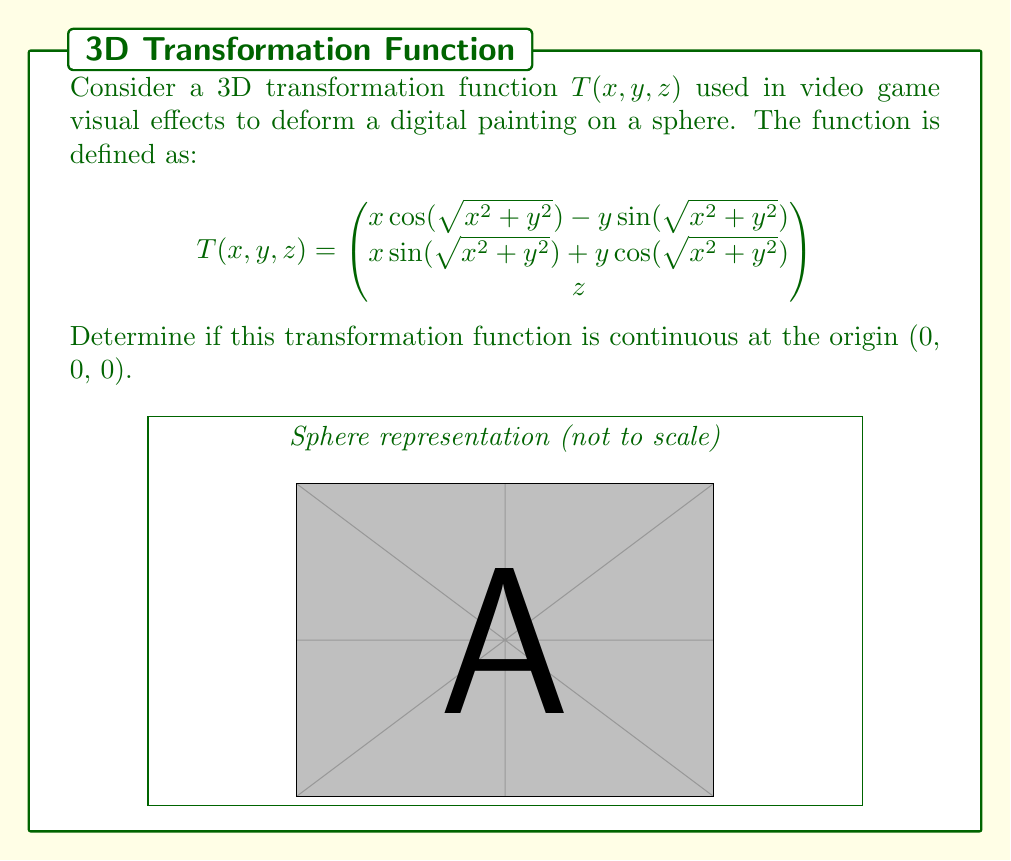Can you answer this question? To determine the continuity of $T(x, y, z)$ at the origin, we need to check if the limit of the function exists as $(x, y, z)$ approaches $(0, 0, 0)$ and if it equals $T(0, 0, 0)$.

Step 1: Evaluate $T(0, 0, 0)$
$$T(0, 0, 0) = \begin{pmatrix}
0\cos(0) - 0\sin(0) \\
0\sin(0) + 0\cos(0) \\
0
\end{pmatrix} = \begin{pmatrix}
0 \\
0 \\
0
\end{pmatrix}$$

Step 2: Examine the limit as $(x, y, z)$ approaches $(0, 0, 0)$

For the first two components:
$$\lim_{(x,y,z)\to(0,0,0)} x\cos(\sqrt{x^2 + y^2}) - y\sin(\sqrt{x^2 + y^2})$$
$$\lim_{(x,y,z)\to(0,0,0)} x\sin(\sqrt{x^2 + y^2}) + y\cos(\sqrt{x^2 + y^2})$$

As $(x, y) \to (0, 0)$, $\sqrt{x^2 + y^2} \to 0$. The sine and cosine terms are bounded, and $x$ and $y$ approach 0, so both these limits equal 0.

For the third component:
$$\lim_{(x,y,z)\to(0,0,0)} z = 0$$

Step 3: Compare the limit to $T(0, 0, 0)$

The limit of $T(x, y, z)$ as $(x, y, z)$ approaches $(0, 0, 0)$ is:
$$\lim_{(x,y,z)\to(0,0,0)} T(x, y, z) = \begin{pmatrix}
0 \\
0 \\
0
\end{pmatrix}$$

This equals $T(0, 0, 0)$, so the function is continuous at the origin.

Step 4: Check for potential issues

The function is well-defined at all points, including the origin. The sine and cosine functions are continuous everywhere, and the square root is continuous for non-negative real numbers, which is always true for $x^2 + y^2$.

Therefore, $T(x, y, z)$ is continuous at the origin (0, 0, 0).
Answer: $T(x, y, z)$ is continuous at (0, 0, 0). 